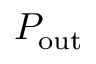Convert formula to latex. <formula><loc_0><loc_0><loc_500><loc_500>P _ { o u t }</formula> 